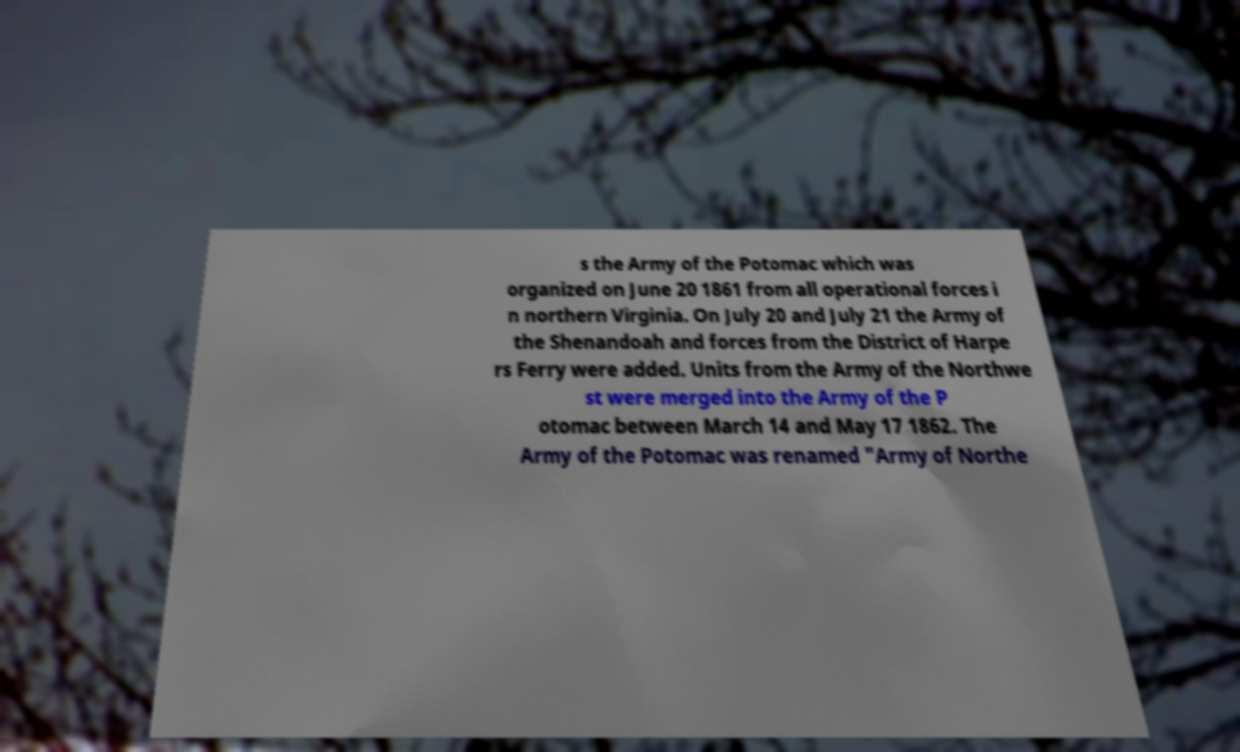Can you read and provide the text displayed in the image?This photo seems to have some interesting text. Can you extract and type it out for me? s the Army of the Potomac which was organized on June 20 1861 from all operational forces i n northern Virginia. On July 20 and July 21 the Army of the Shenandoah and forces from the District of Harpe rs Ferry were added. Units from the Army of the Northwe st were merged into the Army of the P otomac between March 14 and May 17 1862. The Army of the Potomac was renamed "Army of Northe 